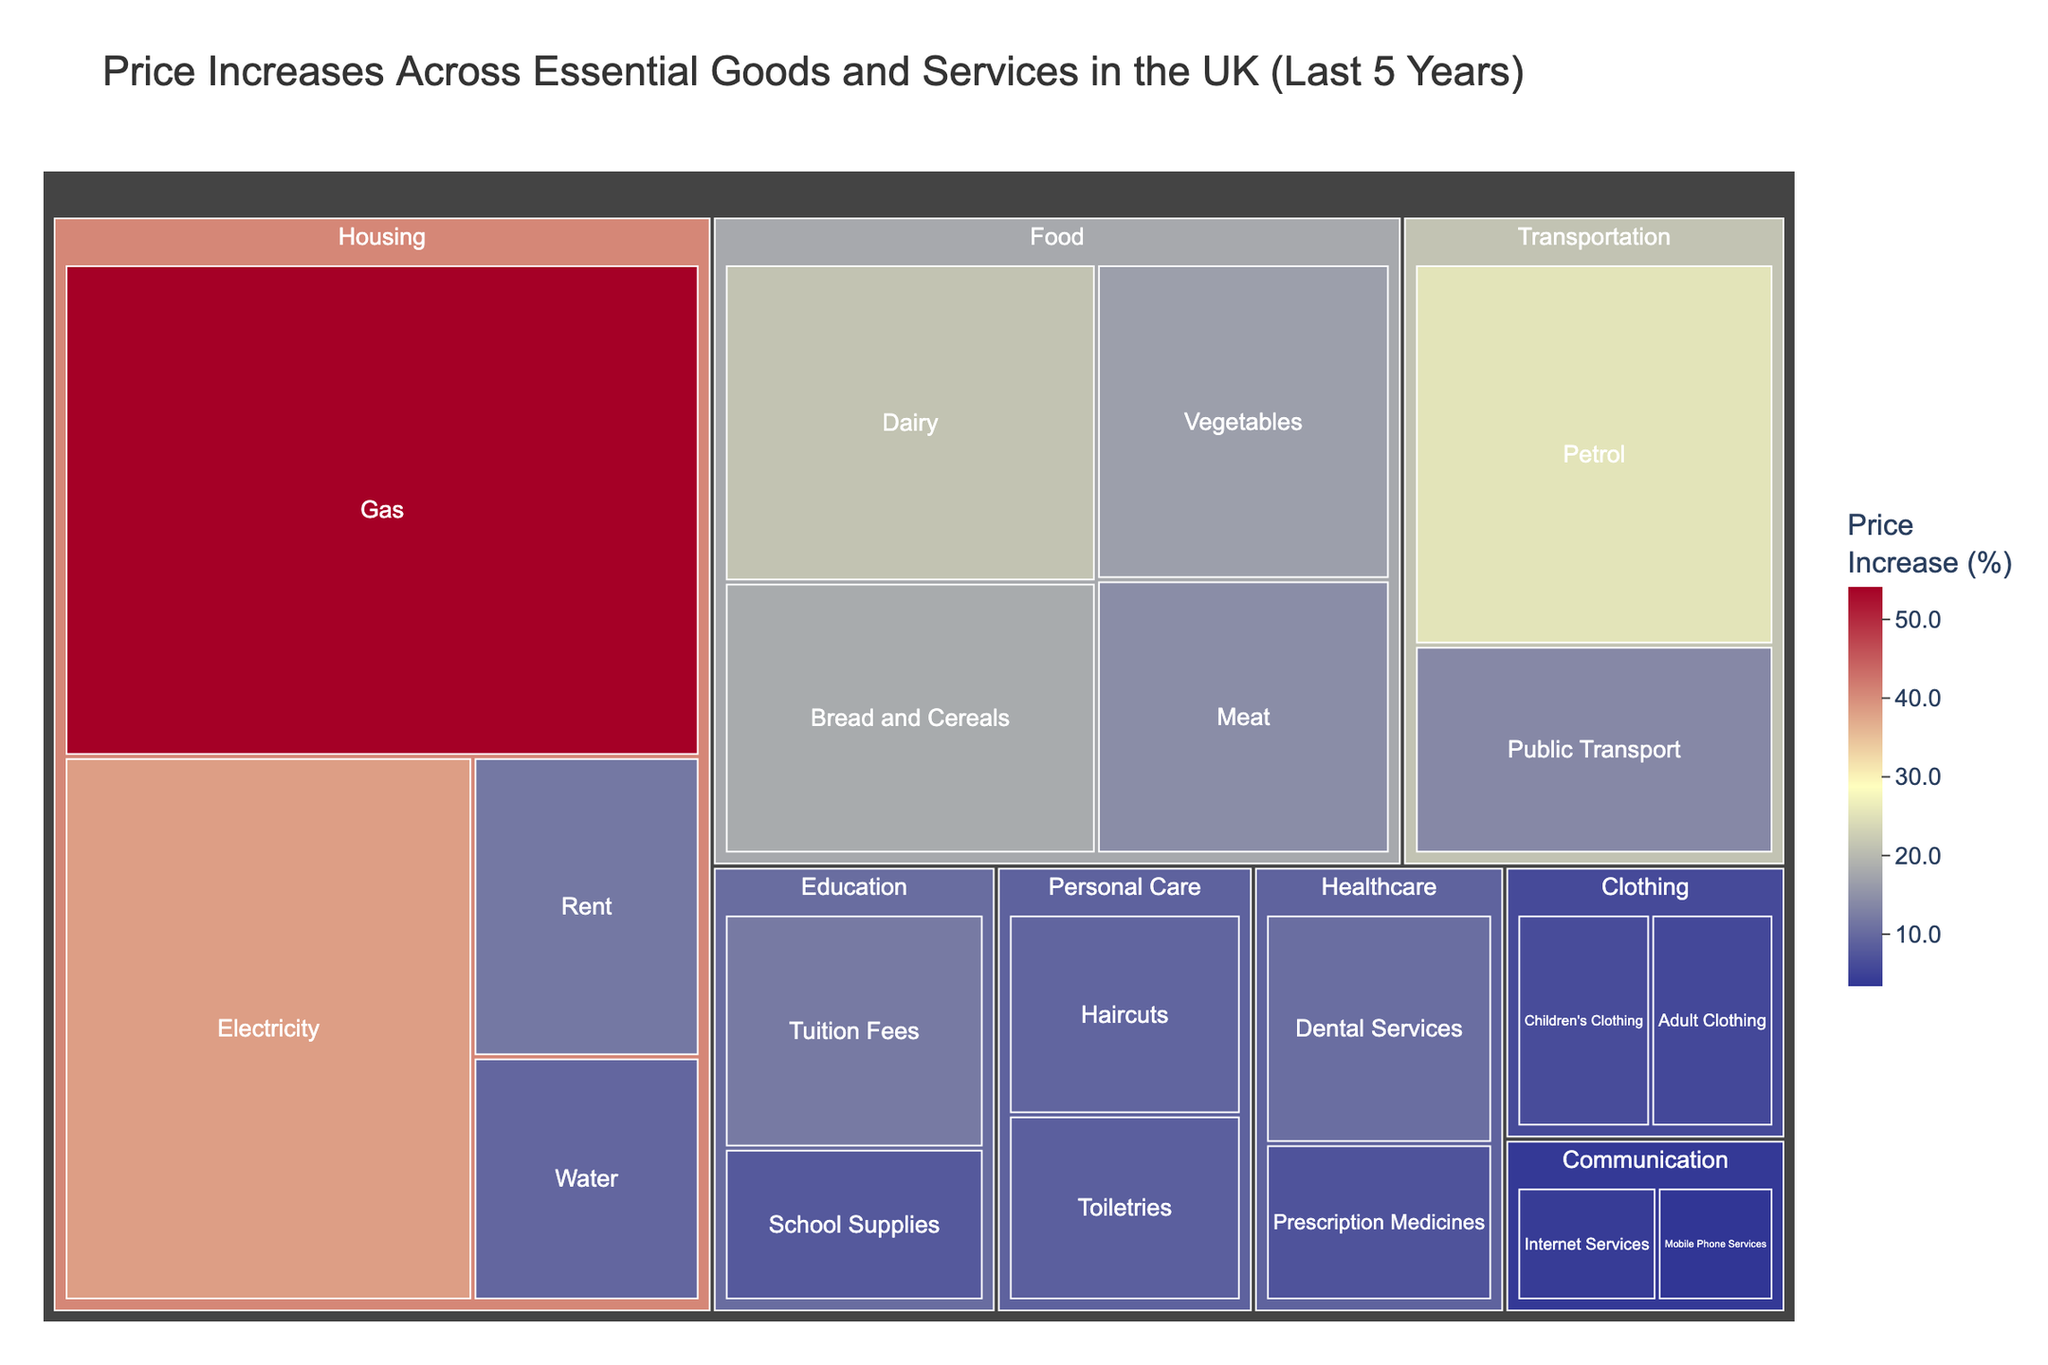What's the title of the figure? The title is displayed prominently at the top of the figure in a large font size. It summarizes the main topic of the visualization.
Answer: Price Increases Across Essential Goods and Services in the UK (Last 5 Years) Which category within the Housing sector has experienced the highest price increase? The treemap uses both the sector and category to structure the data. Within the housing sector, look for the category with the largest value labelled 'Price Increase (%)'.
Answer: Gas What is the price increase (%) for prescription medicines in the Healthcare sector? The treemap has labels and hover information directly overlaying each category. Find the Healthcare sector and locate the category labeled 'Prescription Medicines'.
Answer: 7.2% Which sector shows the highest overall price increase and which category within it has the highest price increase? To find this, identify the sector with the most increased values visually and then look for the highest value within that sector.
Answer: Housing, Gas Compare the price increase between adult clothing and children's clothing. Which one is higher and by how much? Find both categories within the Clothing sector and compare their values. Subtract the smaller value from the larger to find the difference.
Answer: Adult Clothing, 0.5% What is the average price increase across all categories within the Personal Care sector? Locate all the categories under the Personal Care sector and calculate the mean of their values. Add the values and divide by the number of categories.
Answer: (8.7 + 9.4) / 2 = 9.05 Which category in the Food sector has the lowest price increase? Find the Food sector and then look for the category with the smallest value for 'Price Increase (%)'.
Answer: Meat How does the price increase for water in the Housing sector compare to the price increase for electricity? Locate both categories within the Housing sector and compare their values of 'Price Increase (%)'.
Answer: Water is lower than Electricity What is the overall trend in the Transportation sector between Petrol and Public Transport? Look at the 'Price Increase (%)' values for both Petrol and Public Transport in the Transportation sector and describe the difference.
Answer: Petrol has a higher increase than Public Transport Which sector has the lowest average price increase across its categories? Provide the average value. Calculate the average price increase for each sector by summing their categories' values and dividing by the number of categories, then compare these averages to find the lowest.
Answer: Communication, (3.5 + 4.2) / 2 = 3.85 